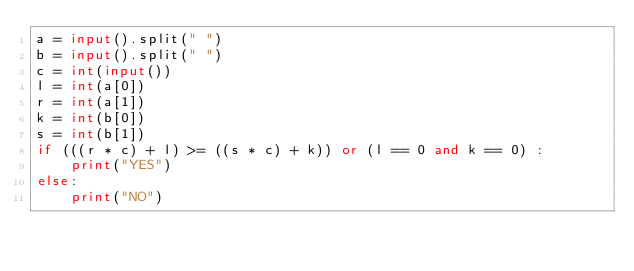<code> <loc_0><loc_0><loc_500><loc_500><_Python_>a = input().split(" ")
b = input().split(" ")
c = int(input())
l = int(a[0])
r = int(a[1])
k = int(b[0])
s = int(b[1])
if (((r * c) + l) >= ((s * c) + k)) or (l == 0 and k == 0) :
    print("YES")
else:
    print("NO")</code> 